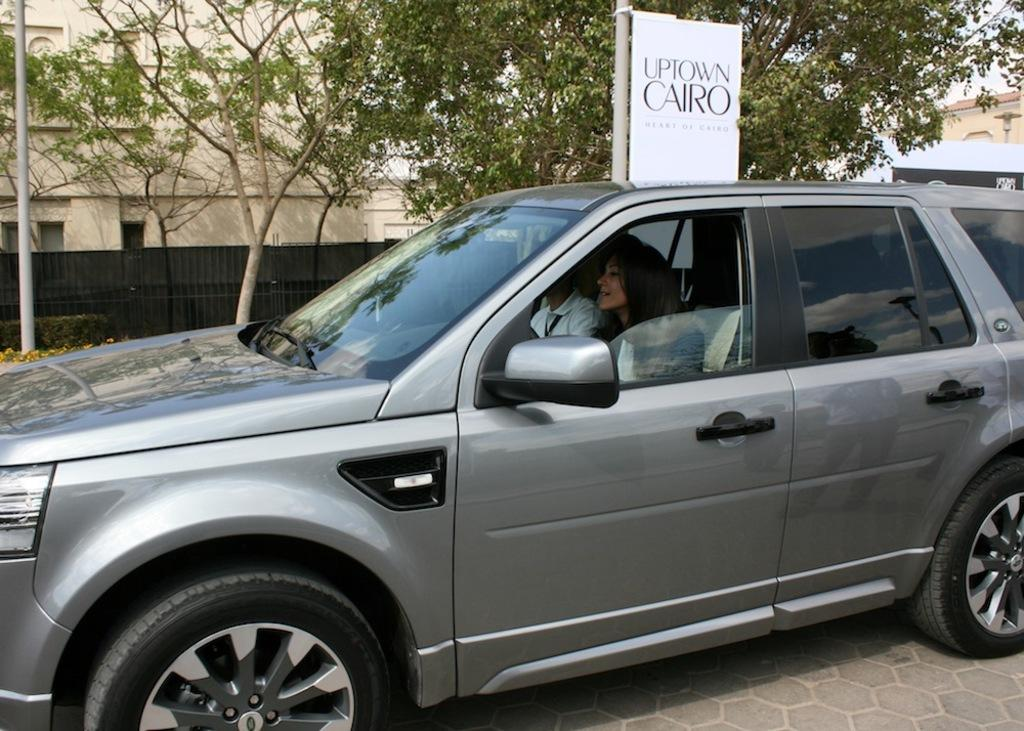How many people are in the image? There are two people in the image, a man and a woman. What are the man and woman doing in the image? The man and woman are sitting in a car. Where is the car located in the image? The car is on a road. What can be seen in the background of the image? There are trees, at least one building, a fence, a pole, and a banner in the background of the image. What type of hat is the porter wearing in the image? There is no porter present in the image, and therefore no hat to describe. 